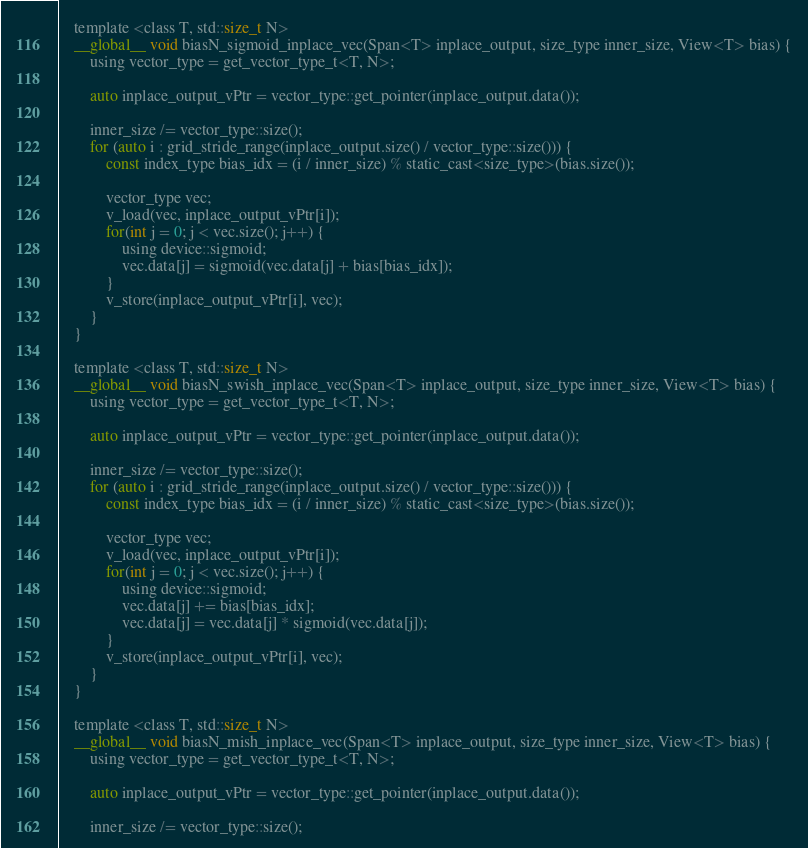Convert code to text. <code><loc_0><loc_0><loc_500><loc_500><_Cuda_>    template <class T, std::size_t N>
    __global__ void biasN_sigmoid_inplace_vec(Span<T> inplace_output, size_type inner_size, View<T> bias) {
        using vector_type = get_vector_type_t<T, N>;

        auto inplace_output_vPtr = vector_type::get_pointer(inplace_output.data());

        inner_size /= vector_type::size();
        for (auto i : grid_stride_range(inplace_output.size() / vector_type::size())) {
            const index_type bias_idx = (i / inner_size) % static_cast<size_type>(bias.size());

            vector_type vec;
            v_load(vec, inplace_output_vPtr[i]);
            for(int j = 0; j < vec.size(); j++) {
                using device::sigmoid;
                vec.data[j] = sigmoid(vec.data[j] + bias[bias_idx]);
            }
            v_store(inplace_output_vPtr[i], vec);
        }
    }

    template <class T, std::size_t N>
    __global__ void biasN_swish_inplace_vec(Span<T> inplace_output, size_type inner_size, View<T> bias) {
        using vector_type = get_vector_type_t<T, N>;

        auto inplace_output_vPtr = vector_type::get_pointer(inplace_output.data());

        inner_size /= vector_type::size();
        for (auto i : grid_stride_range(inplace_output.size() / vector_type::size())) {
            const index_type bias_idx = (i / inner_size) % static_cast<size_type>(bias.size());

            vector_type vec;
            v_load(vec, inplace_output_vPtr[i]);
            for(int j = 0; j < vec.size(); j++) {
                using device::sigmoid;
                vec.data[j] += bias[bias_idx];
                vec.data[j] = vec.data[j] * sigmoid(vec.data[j]);
            }
            v_store(inplace_output_vPtr[i], vec);
        }
    }

    template <class T, std::size_t N>
    __global__ void biasN_mish_inplace_vec(Span<T> inplace_output, size_type inner_size, View<T> bias) {
        using vector_type = get_vector_type_t<T, N>;

        auto inplace_output_vPtr = vector_type::get_pointer(inplace_output.data());

        inner_size /= vector_type::size();</code> 